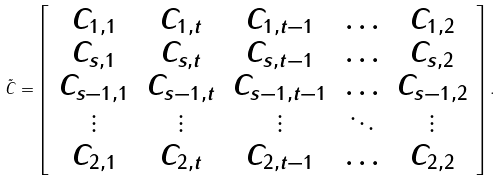<formula> <loc_0><loc_0><loc_500><loc_500>\tilde { C } = \left [ \begin{array} { c c c c c } C _ { 1 , 1 } & C _ { 1 , t } & C _ { 1 , t - 1 } & \hdots & C _ { 1 , 2 } \\ C _ { s , 1 } & C _ { s , t } & C _ { s , t - 1 } & \hdots & C _ { s , 2 } \\ C _ { s - 1 , 1 } & C _ { s - 1 , t } & C _ { s - 1 , t - 1 } & \hdots & C _ { s - 1 , 2 } \\ \vdots & \vdots & \vdots & \ddots & \vdots \\ C _ { 2 , 1 } & C _ { 2 , t } & C _ { 2 , t - 1 } & \hdots & C _ { 2 , 2 } \\ \end{array} \right ] .</formula> 